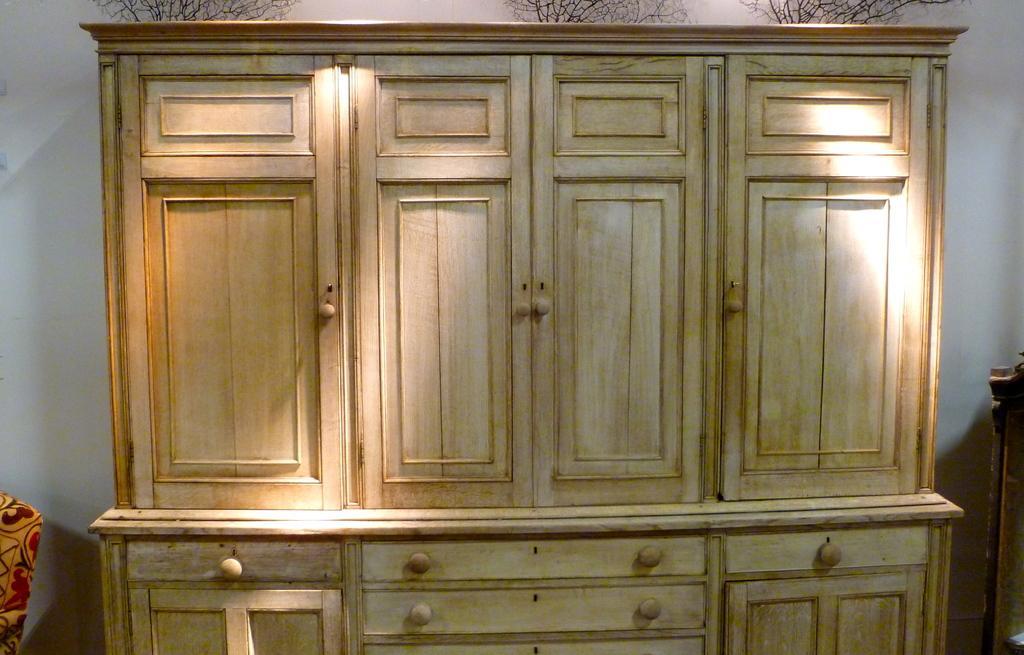How would you summarize this image in a sentence or two? In this image I can see the cupboard which is in cream color. To the left I can see the yellow and red color cloth. In the background I can see the white sky. 